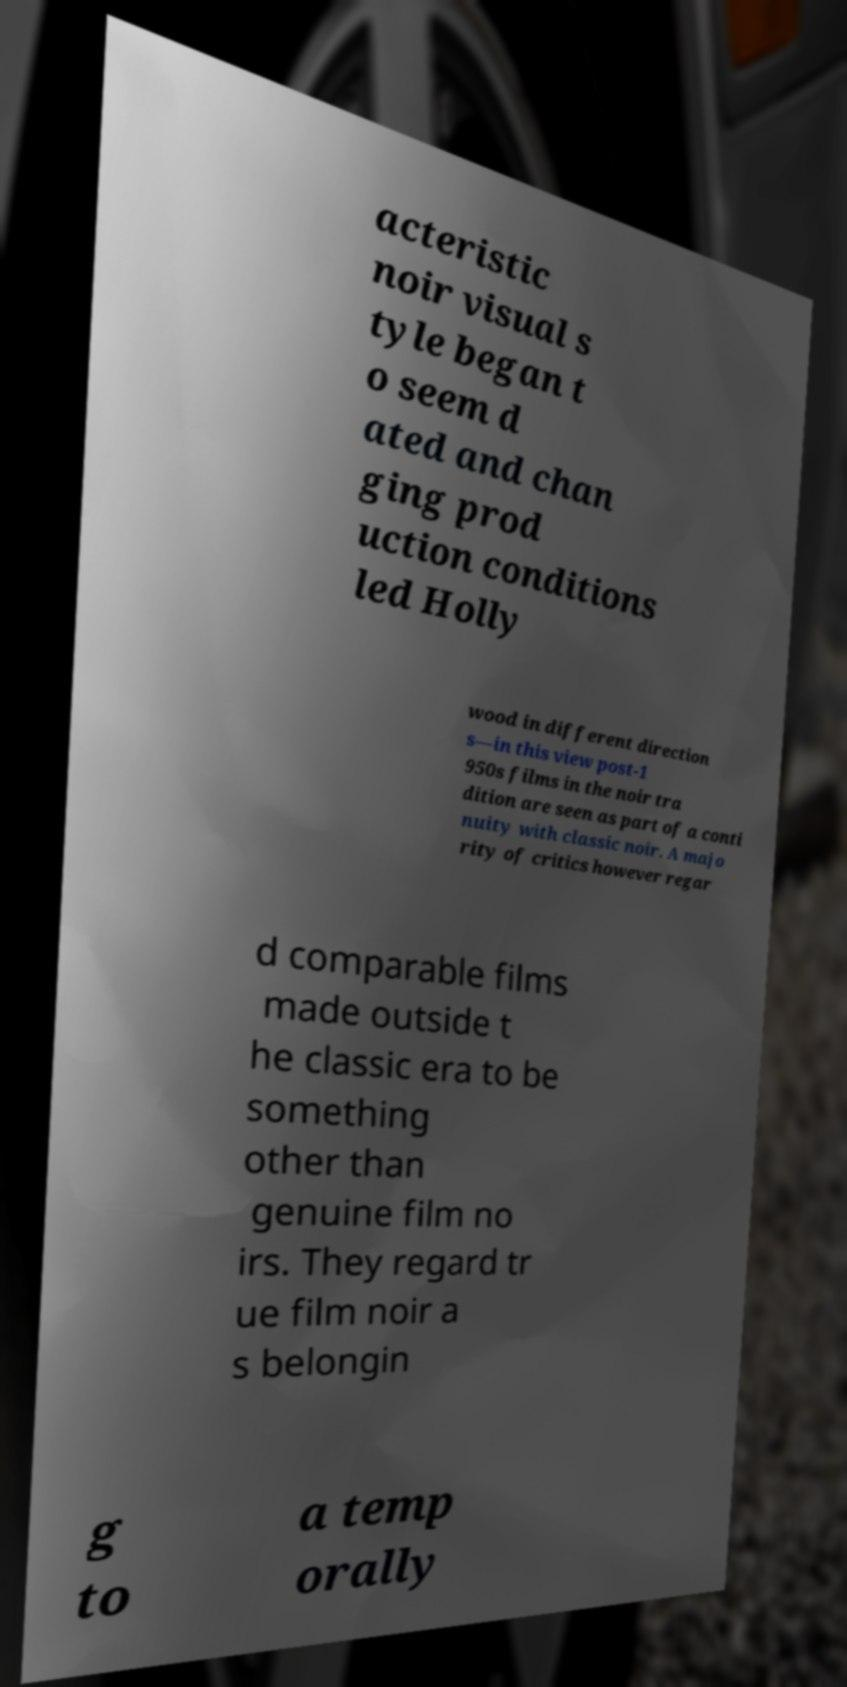Could you assist in decoding the text presented in this image and type it out clearly? acteristic noir visual s tyle began t o seem d ated and chan ging prod uction conditions led Holly wood in different direction s—in this view post-1 950s films in the noir tra dition are seen as part of a conti nuity with classic noir. A majo rity of critics however regar d comparable films made outside t he classic era to be something other than genuine film no irs. They regard tr ue film noir a s belongin g to a temp orally 